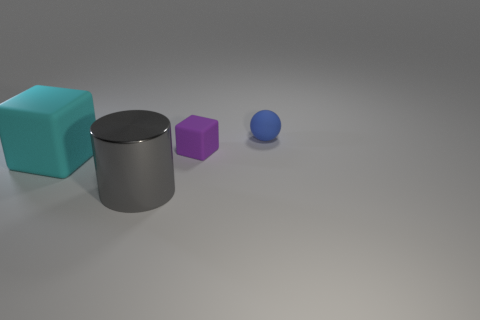Is the shape of the shiny thing the same as the small blue object?
Make the answer very short. No. There is a block that is behind the big cyan matte block; what color is it?
Ensure brevity in your answer.  Purple. What is the shape of the other metallic thing that is the same size as the cyan object?
Keep it short and to the point. Cylinder. There is a metallic cylinder; is it the same color as the big object behind the big gray metallic cylinder?
Ensure brevity in your answer.  No. How many objects are either rubber objects on the left side of the big gray metallic cylinder or matte objects that are left of the gray object?
Provide a succinct answer. 1. There is a thing that is the same size as the shiny cylinder; what is it made of?
Give a very brief answer. Rubber. What number of other objects are there of the same material as the tiny purple thing?
Offer a terse response. 2. There is a small rubber object that is in front of the ball; is its shape the same as the tiny object on the right side of the tiny purple thing?
Your answer should be very brief. No. There is a object that is in front of the matte object that is in front of the small rubber thing that is in front of the rubber sphere; what is its color?
Provide a succinct answer. Gray. What number of other objects are there of the same color as the small block?
Provide a short and direct response. 0. 